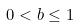Convert formula to latex. <formula><loc_0><loc_0><loc_500><loc_500>0 < b \leq 1</formula> 